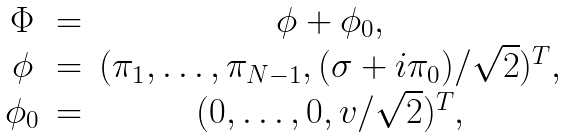Convert formula to latex. <formula><loc_0><loc_0><loc_500><loc_500>\begin{array} { c c c } \Phi & = & \phi + \phi _ { 0 } , \\ \phi & = & ( \pi _ { 1 } , \dots , \pi _ { N - 1 } , ( \sigma + i \pi _ { 0 } ) / \sqrt { 2 } ) ^ { T } , \\ \phi _ { 0 } & = & ( 0 , \dots , 0 , v / \sqrt { 2 } ) ^ { T } , \end{array}</formula> 